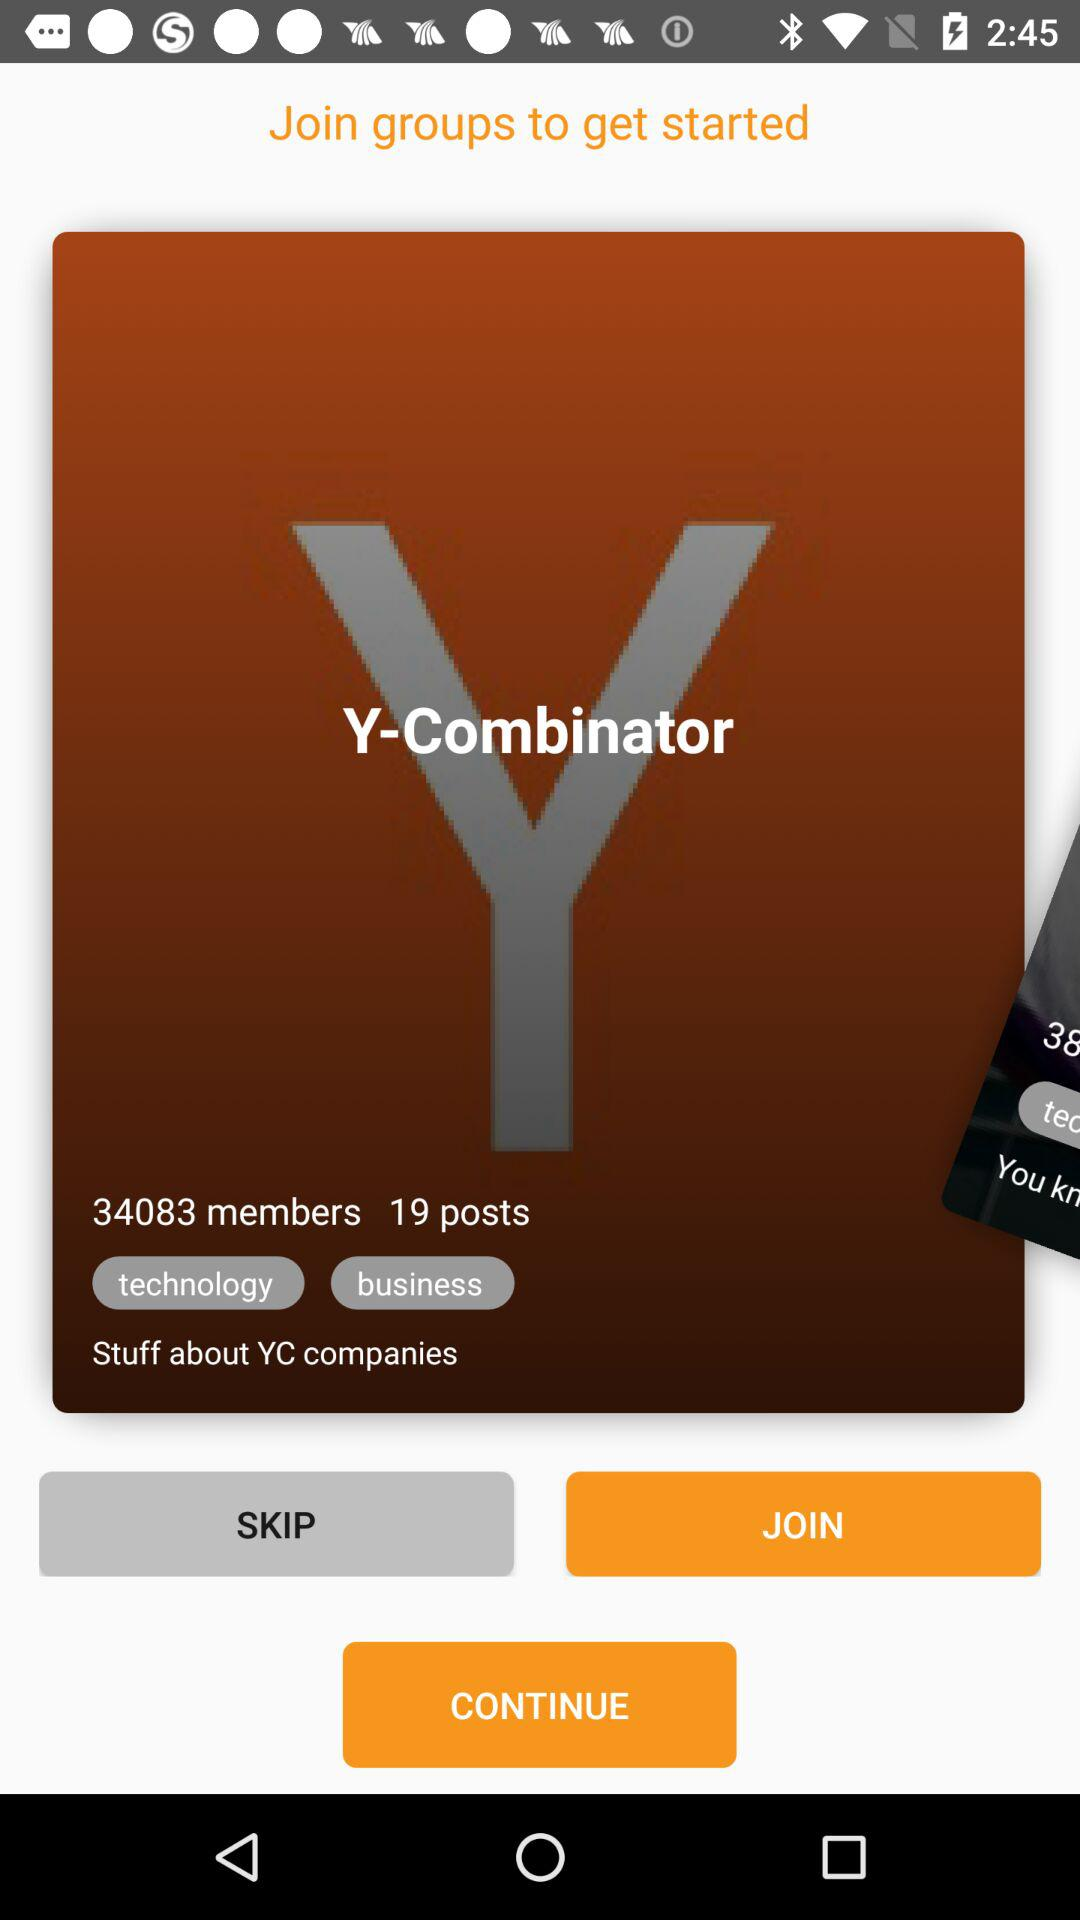What is the name of the group? The name of the group is "Y-Combinator". 